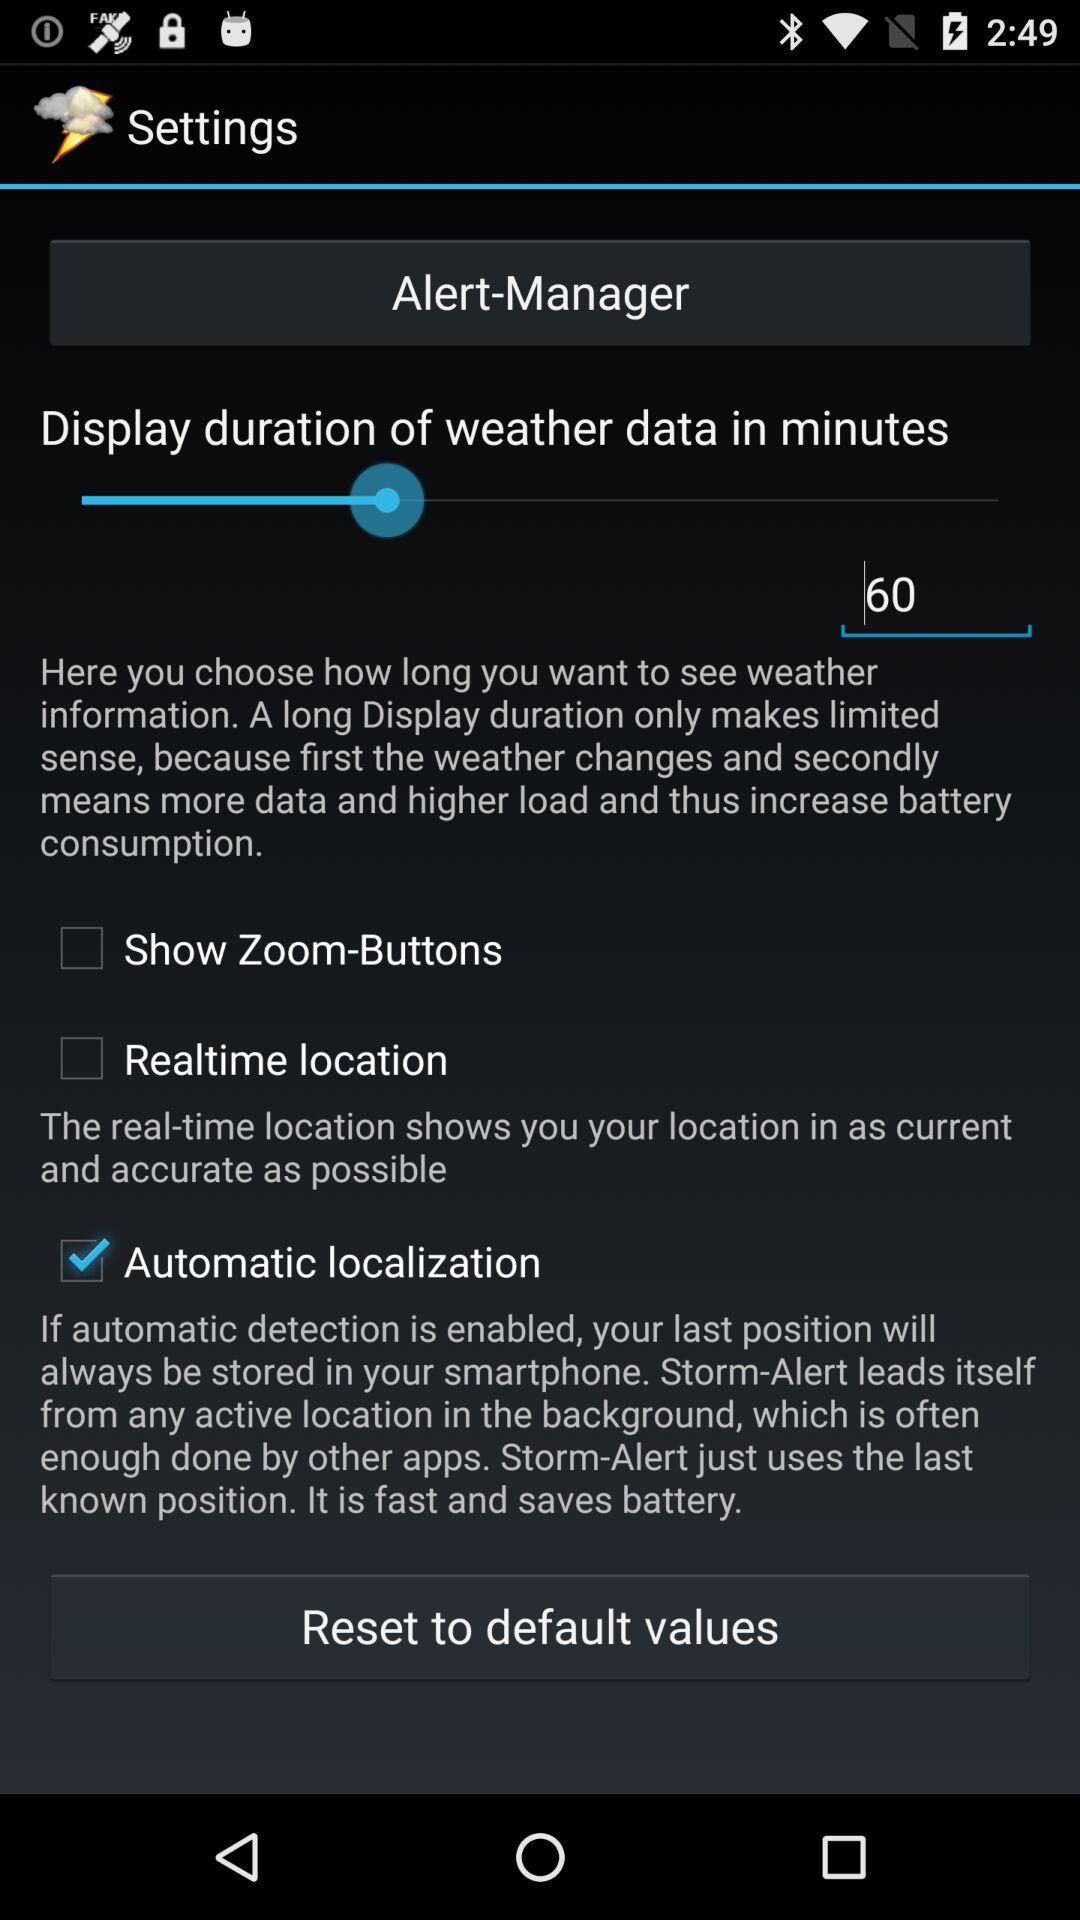How many checkbox options are there?
Answer the question using a single word or phrase. 3 